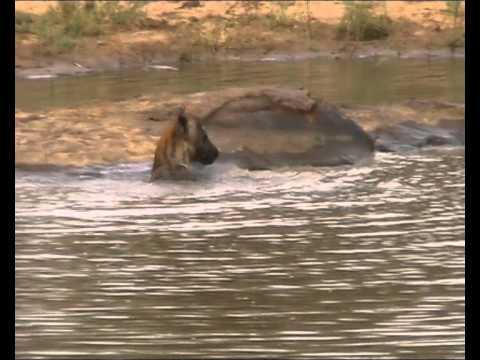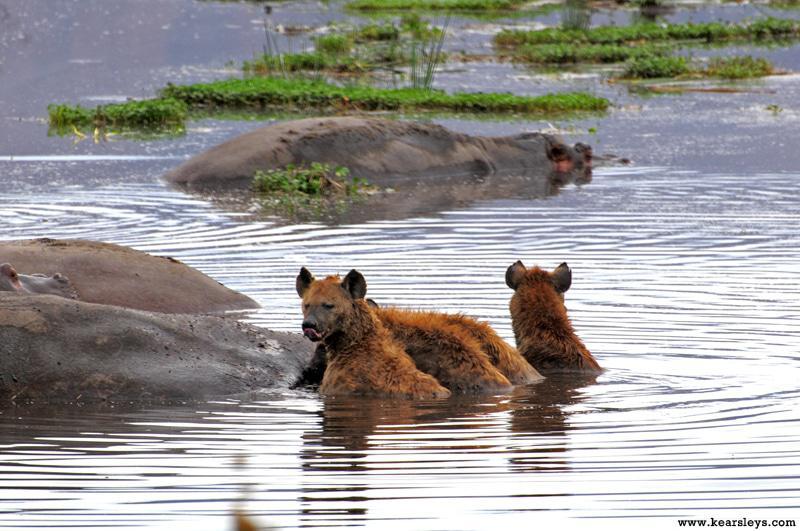The first image is the image on the left, the second image is the image on the right. Evaluate the accuracy of this statement regarding the images: "The left and right image contains the same number of hyenas in the water.". Is it true? Answer yes or no. No. The first image is the image on the left, the second image is the image on the right. Evaluate the accuracy of this statement regarding the images: "The right image shows one hyena on its back in water, with its head and at least its front paws sticking up in the air.". Is it true? Answer yes or no. No. 